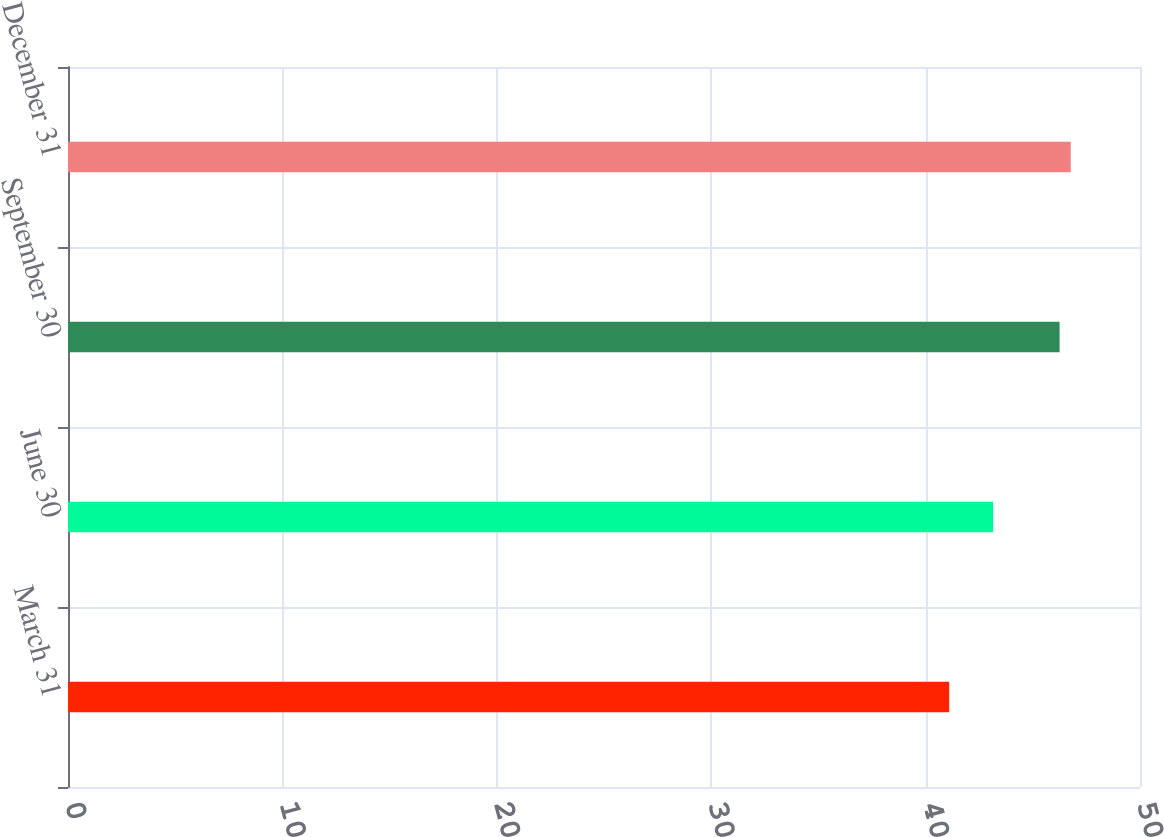Convert chart to OTSL. <chart><loc_0><loc_0><loc_500><loc_500><bar_chart><fcel>March 31<fcel>June 30<fcel>September 30<fcel>December 31<nl><fcel>41.1<fcel>43.15<fcel>46.25<fcel>46.77<nl></chart> 